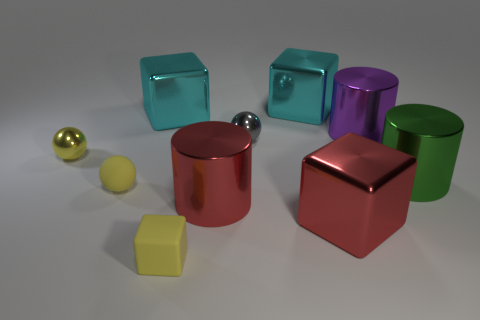Is there a red metal cylinder of the same size as the rubber ball? no 